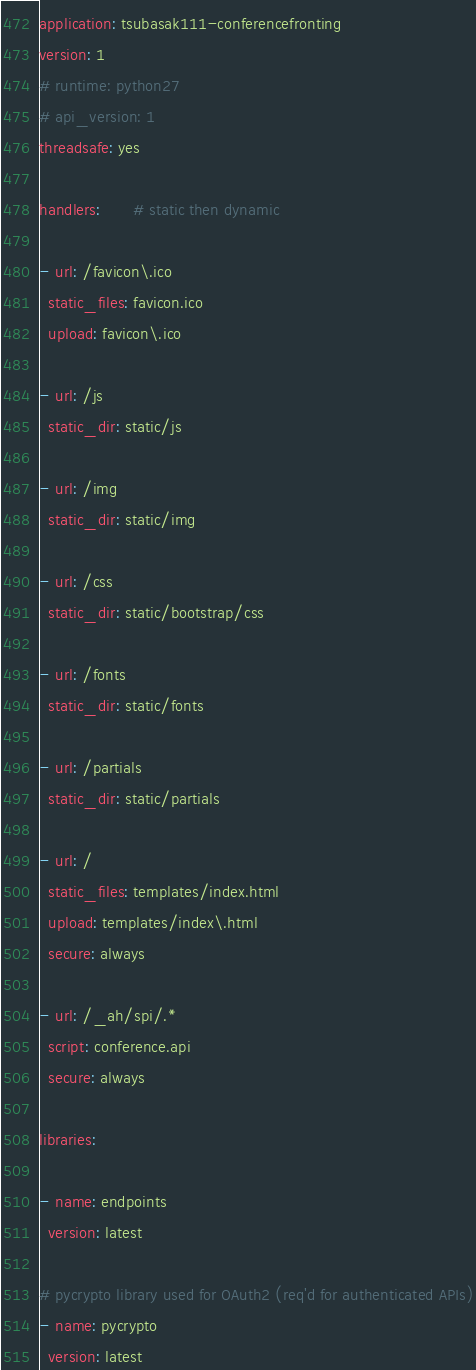Convert code to text. <code><loc_0><loc_0><loc_500><loc_500><_YAML_>application: tsubasak111-conferencefronting
version: 1
# runtime: python27
# api_version: 1
threadsafe: yes

handlers:       # static then dynamic

- url: /favicon\.ico
  static_files: favicon.ico
  upload: favicon\.ico

- url: /js
  static_dir: static/js

- url: /img
  static_dir: static/img

- url: /css
  static_dir: static/bootstrap/css

- url: /fonts
  static_dir: static/fonts

- url: /partials
  static_dir: static/partials

- url: /
  static_files: templates/index.html
  upload: templates/index\.html
  secure: always

- url: /_ah/spi/.*
  script: conference.api
  secure: always

libraries:

- name: endpoints
  version: latest

# pycrypto library used for OAuth2 (req'd for authenticated APIs)
- name: pycrypto
  version: latest
</code> 